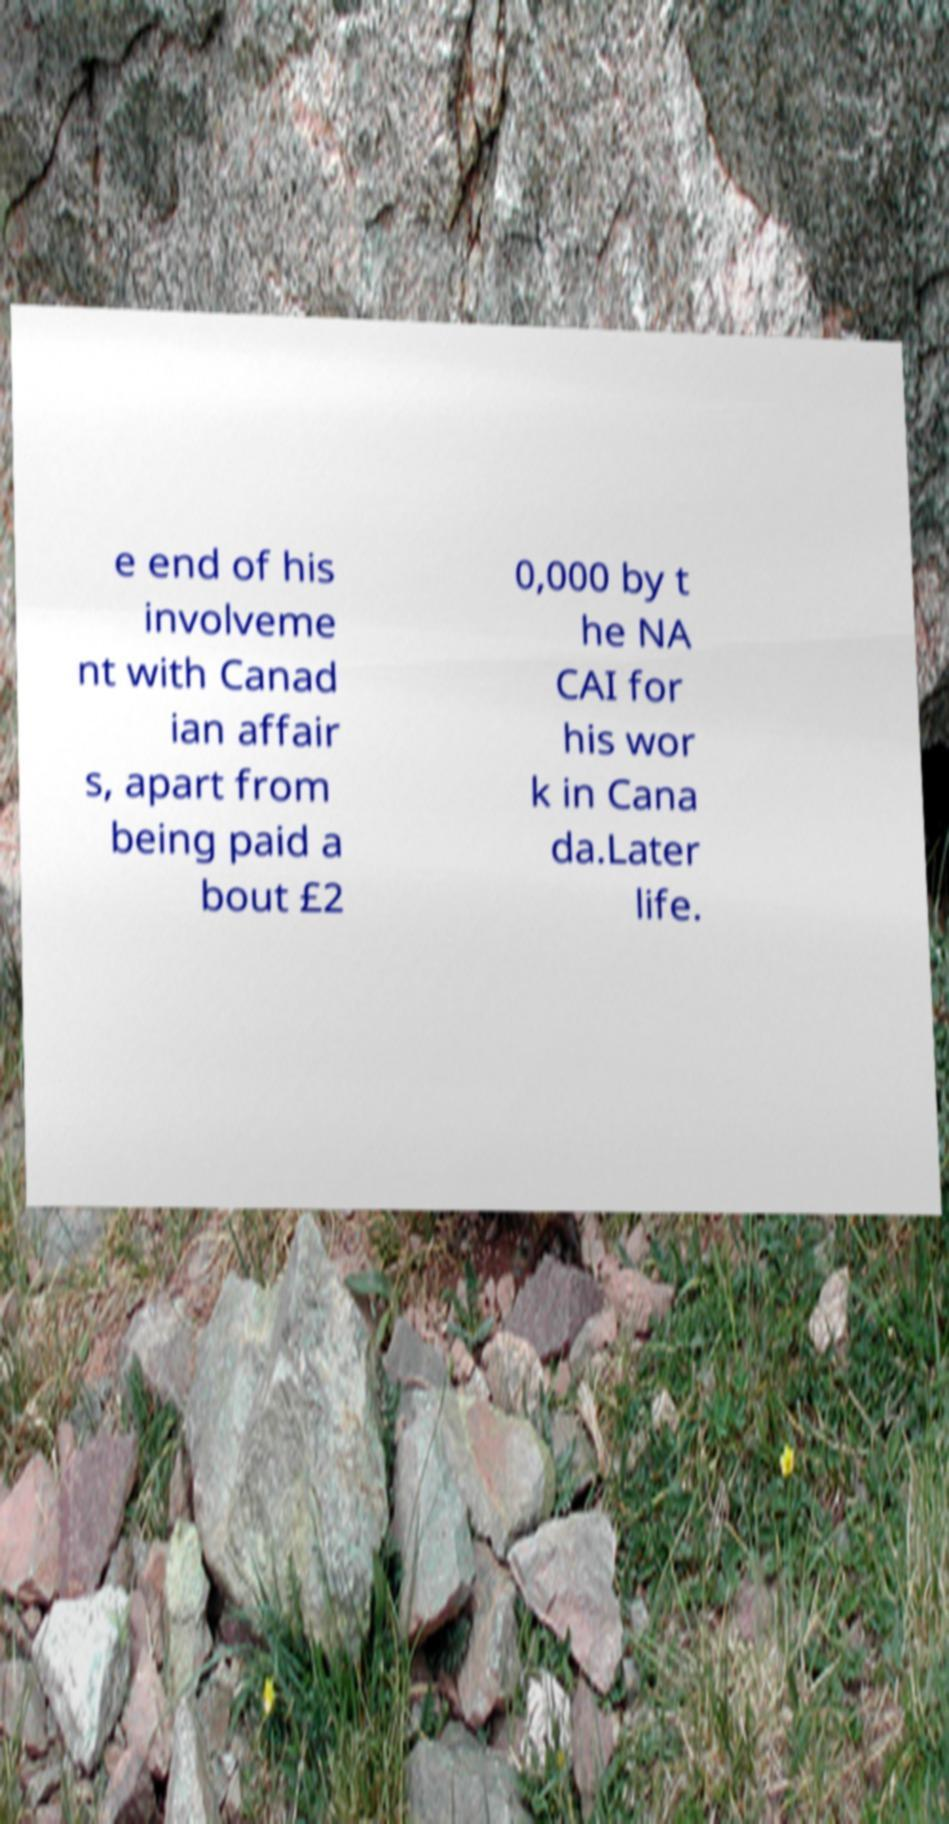Please read and relay the text visible in this image. What does it say? e end of his involveme nt with Canad ian affair s, apart from being paid a bout £2 0,000 by t he NA CAI for his wor k in Cana da.Later life. 